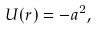Convert formula to latex. <formula><loc_0><loc_0><loc_500><loc_500>U ( r ) = - a ^ { 2 } ,</formula> 